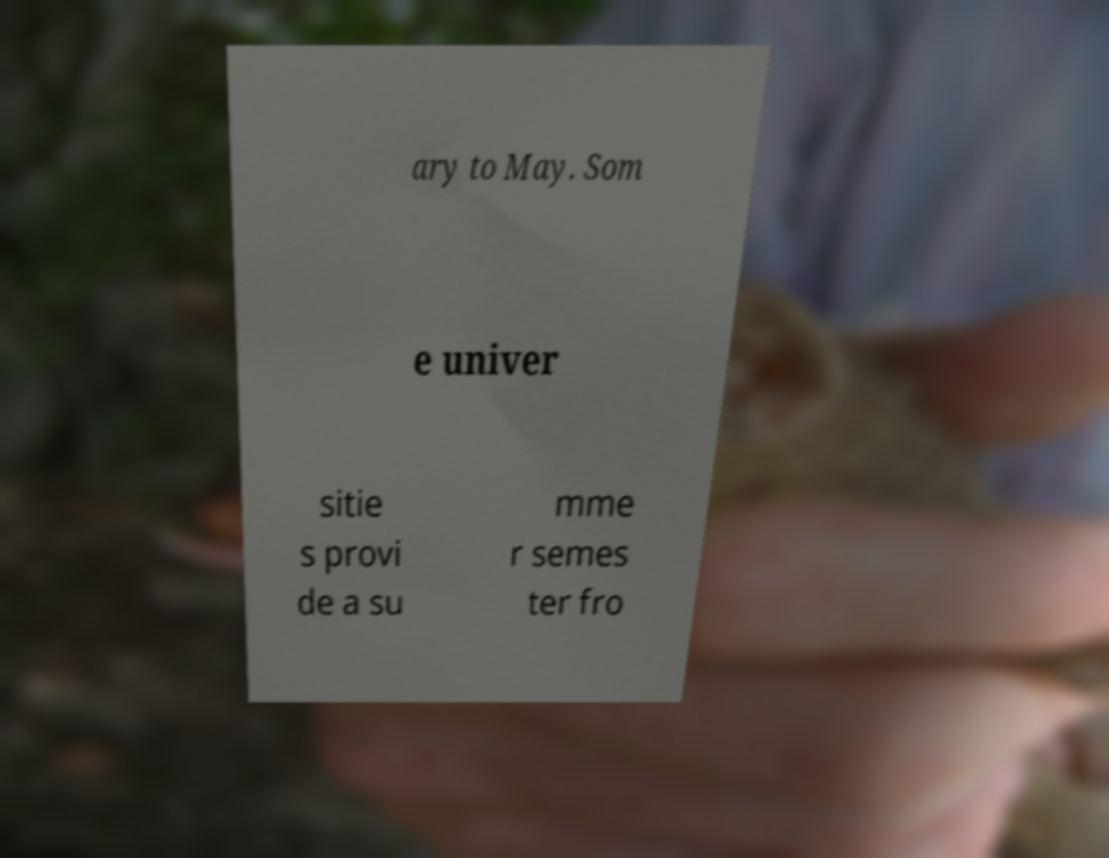Can you accurately transcribe the text from the provided image for me? ary to May. Som e univer sitie s provi de a su mme r semes ter fro 